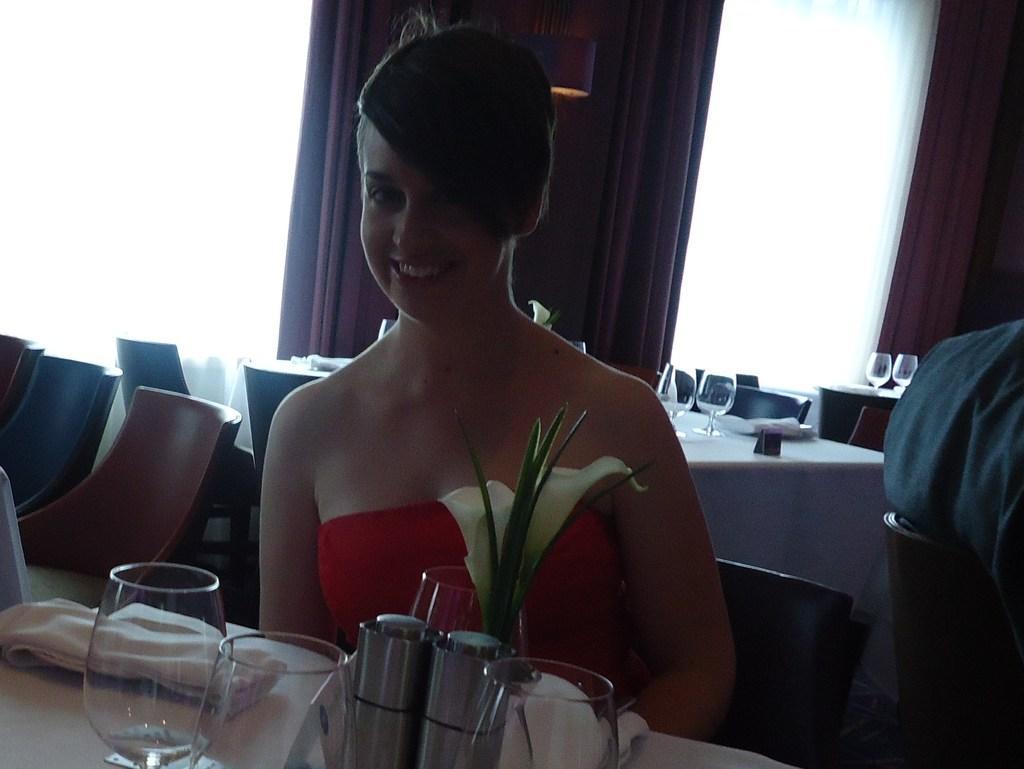Describe this image in one or two sentences. In the image we can see there is a woman who is sitting on chair. 